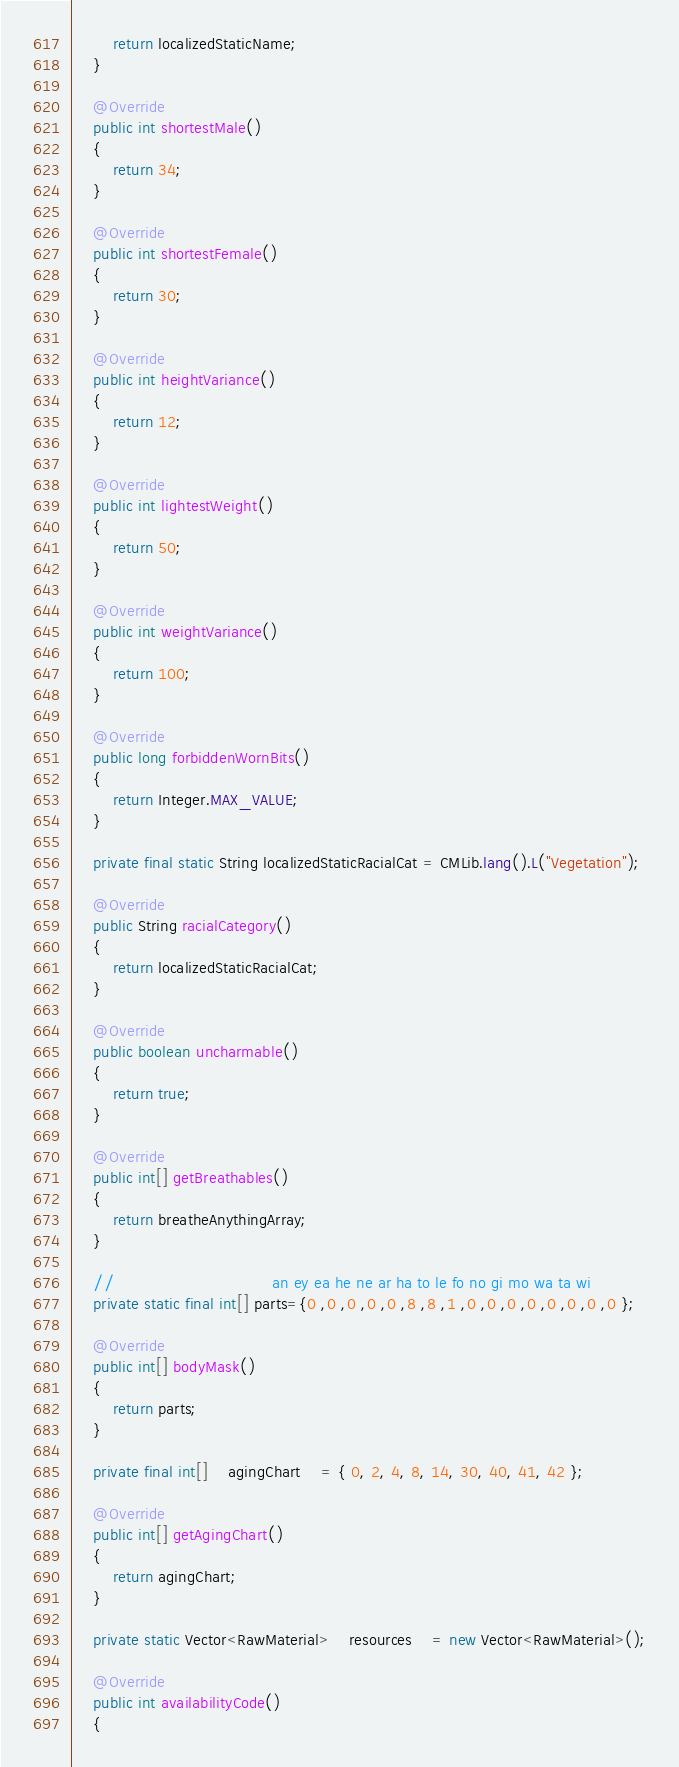<code> <loc_0><loc_0><loc_500><loc_500><_Java_>		return localizedStaticName;
	}

	@Override
	public int shortestMale()
	{
		return 34;
	}

	@Override
	public int shortestFemale()
	{
		return 30;
	}

	@Override
	public int heightVariance()
	{
		return 12;
	}

	@Override
	public int lightestWeight()
	{
		return 50;
	}

	@Override
	public int weightVariance()
	{
		return 100;
	}

	@Override
	public long forbiddenWornBits()
	{
		return Integer.MAX_VALUE;
	}

	private final static String localizedStaticRacialCat = CMLib.lang().L("Vegetation");

	@Override
	public String racialCategory()
	{
		return localizedStaticRacialCat;
	}

	@Override
	public boolean uncharmable()
	{
		return true;
	}

	@Override
	public int[] getBreathables()
	{
		return breatheAnythingArray;
	}

	//  							  an ey ea he ne ar ha to le fo no gi mo wa ta wi
	private static final int[] parts={0 ,0 ,0 ,0 ,0 ,8 ,8 ,1 ,0 ,0 ,0 ,0 ,0 ,0 ,0 ,0 };

	@Override
	public int[] bodyMask()
	{
		return parts;
	}

	private final int[]	agingChart	= { 0, 2, 4, 8, 14, 30, 40, 41, 42 };

	@Override
	public int[] getAgingChart()
	{
		return agingChart;
	}

	private static Vector<RawMaterial>	resources	= new Vector<RawMaterial>();

	@Override
	public int availabilityCode()
	{</code> 